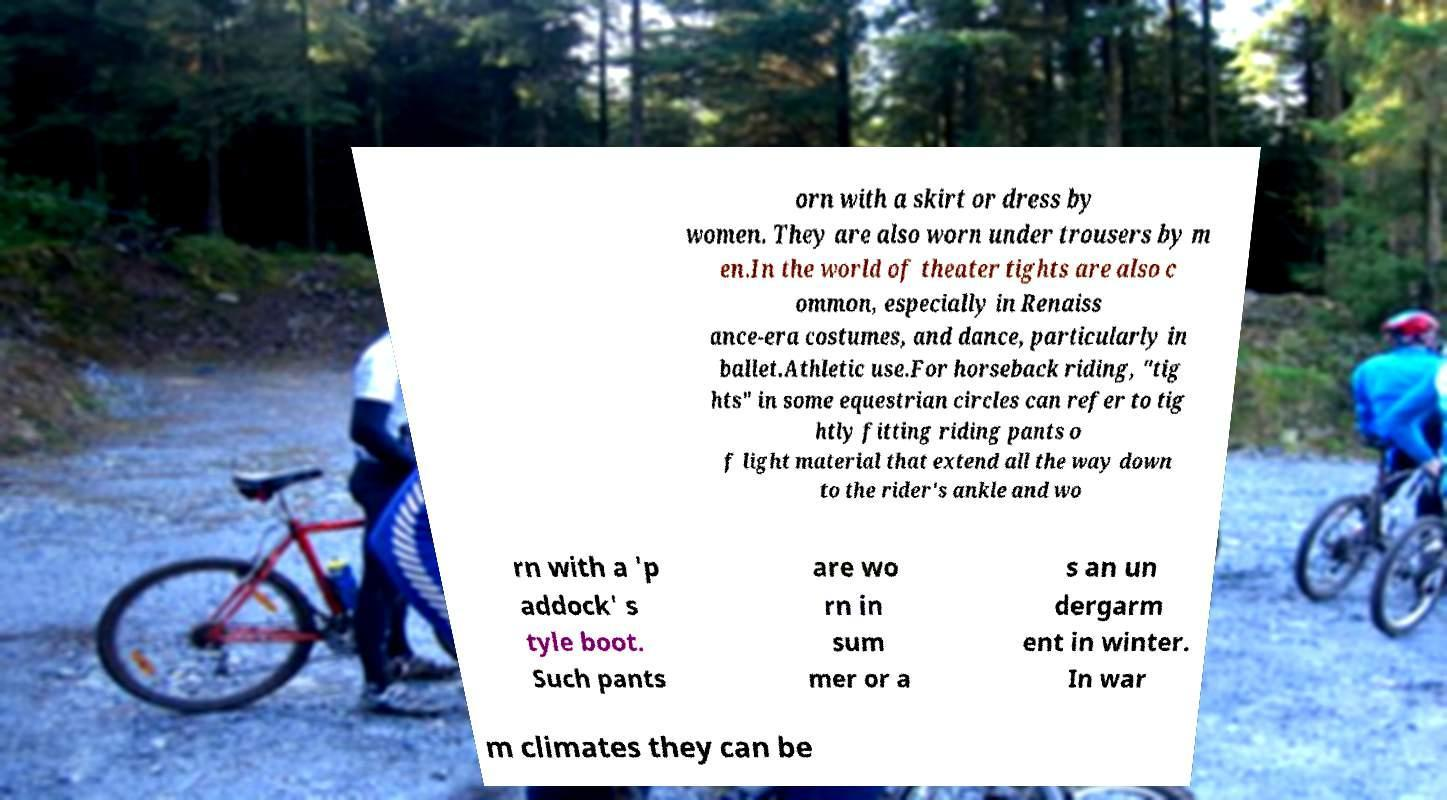Please read and relay the text visible in this image. What does it say? orn with a skirt or dress by women. They are also worn under trousers by m en.In the world of theater tights are also c ommon, especially in Renaiss ance-era costumes, and dance, particularly in ballet.Athletic use.For horseback riding, "tig hts" in some equestrian circles can refer to tig htly fitting riding pants o f light material that extend all the way down to the rider's ankle and wo rn with a 'p addock' s tyle boot. Such pants are wo rn in sum mer or a s an un dergarm ent in winter. In war m climates they can be 